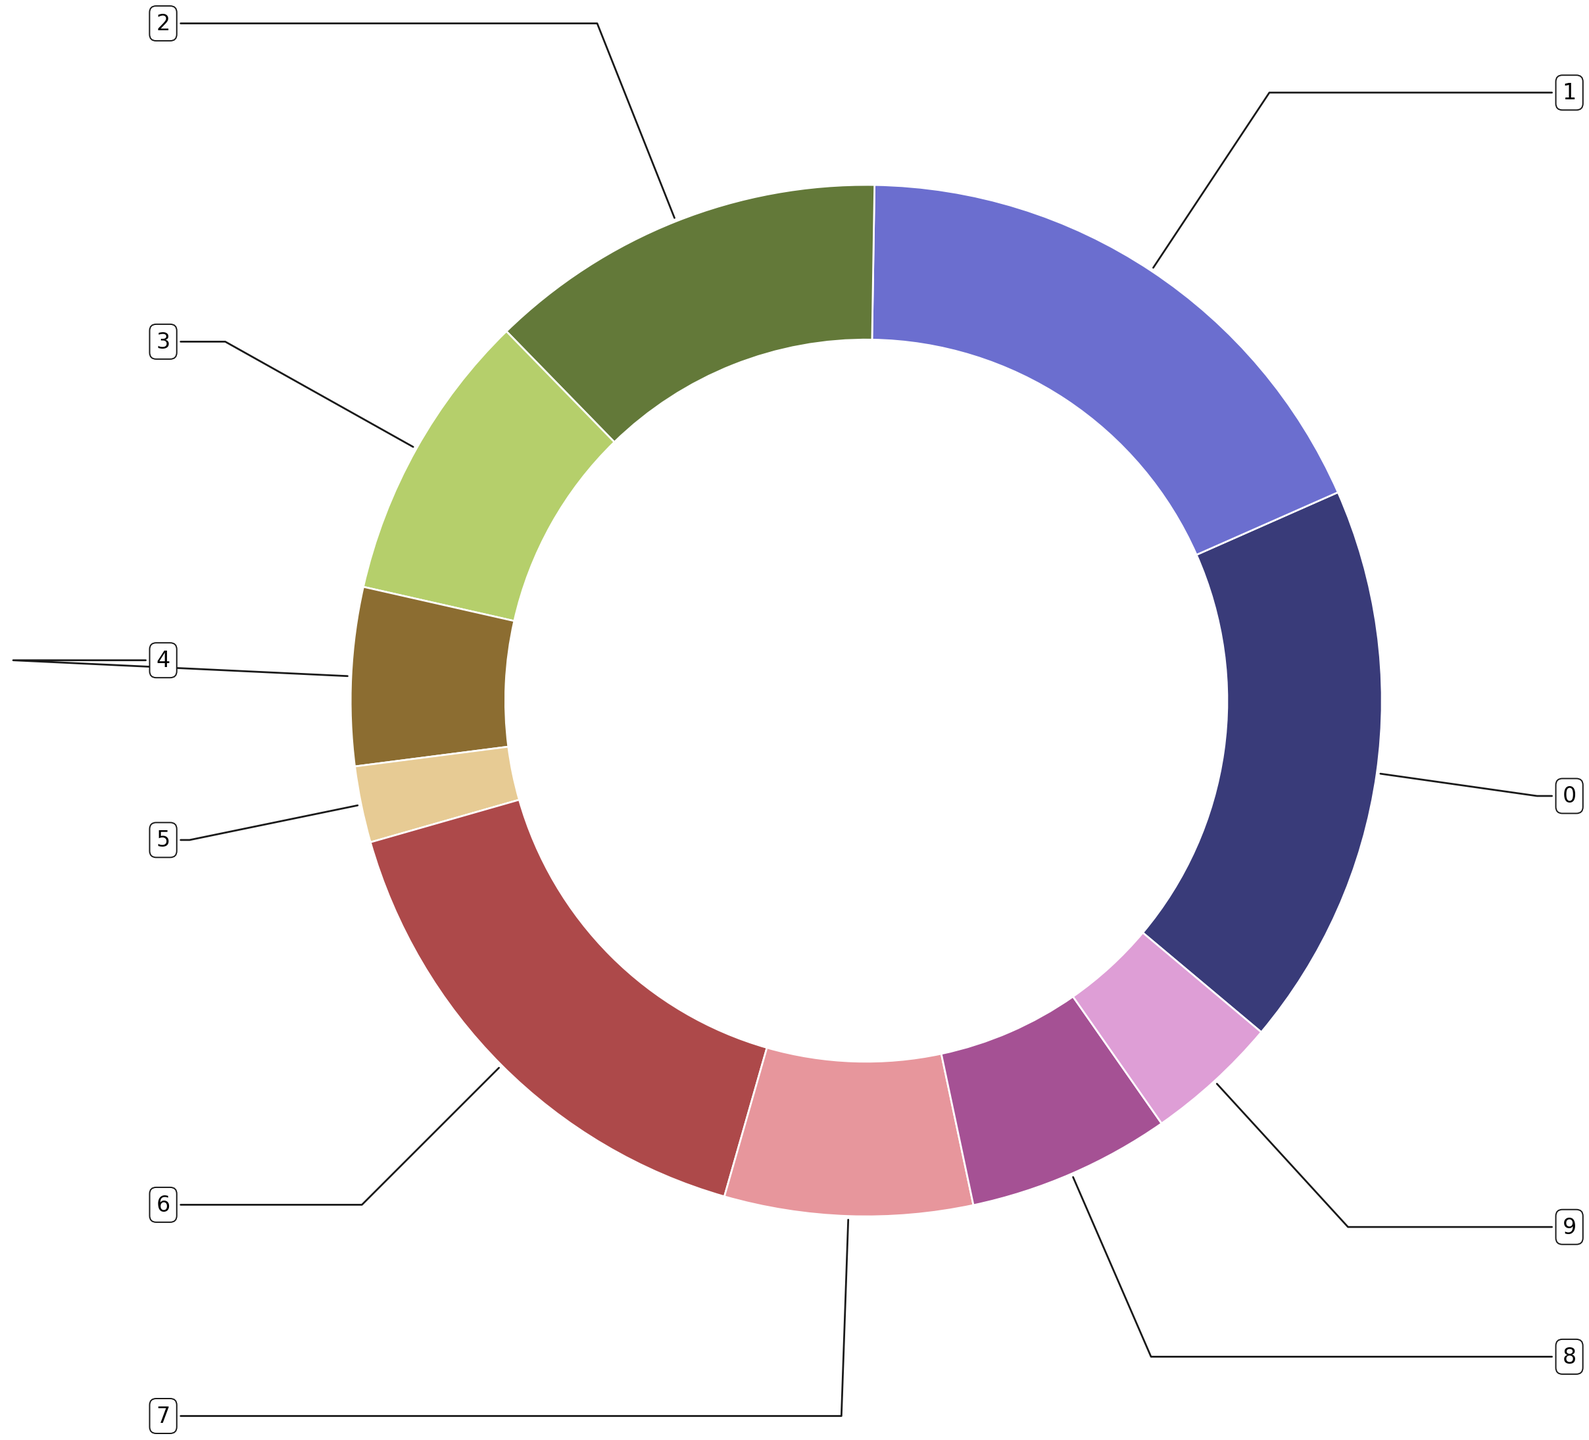What customer demographic has the highest total usage of self-service technologies? The ring chart shows different wedges for customer demographics. The largest wedge, representing the highest total usage, is for the demographic "Female." This can be observed by the relative size of the wedges.
Answer: Female Which age group within the “Male” demographic uses self-service technologies the most? Looking at the portion of the ring corresponding to the "Male" demographic, the largest slice belongs to the 25-34 age group. This indicates that this age group has the highest usage.
Answer: 25-34 What is the total usage of self-service technologies for males aged 18-24 and 25-34 combined? First, identify the individual usage values for males aged 18-24 and 25-34, which are 14 and 22, respectively. Then sum these values: 14 + 22 = 36.
Answer: 36 Which income group shows the highest usage of self-service technologies for age 55-64? By observing the sizes of the wedges within the age 55-64 segment for different income groups, the largest wedge belongs to the <$30k income group.
Answer: <$30k How does the usage of self-service technologies by females aged 35-44 compare to that of males in the same age group? Locate the wedges for females and males aged 35-44. The usage values are 21 for females and 20 for males. Comparatively, females aged 35-44 use self-service technologies more than males.
Answer: Females use more What is the average usage of self-service technologies for the age group 45-54 across all education levels? Identify the values for the age group 45-54 across all education levels: High School or Less (12), Some College (9), Bachelor's Degree (7), and Advanced Degree (3). Sum these values: 12 + 9 + 7 + 3 = 31. There are 4 groups, so divide the total by 4 to find the average: 31/4 = 7.75.
Answer: 7.75 Comparing the 65+ age group, which has lower total usage: those with a Bachelor's Degree or those with an Advanced Degree? Locate the wedges for the age group 65+ for both Bachelor's Degree and Advanced Degree. The values are 1 for a Bachelor's Degree and 0 for an Advanced Degree. Thus, the group with an Advanced Degree has a lower total usage.
Answer: Advanced Degree What is the combined usage of self-service technologies for the demographic with the highest total usage and the demographic with the lowest total usage? Identify the demographic with the highest and lowest usage. The highest is Female with values 13, 23, 21, 18, 11, and 5 (totaling 91). For the lowest usage, it's Advanced Degree with values 1, 3, 4, 3, 1, and 0 (totaling 12). Summing these totals: 91 + 12 = 103.
Answer: 103 